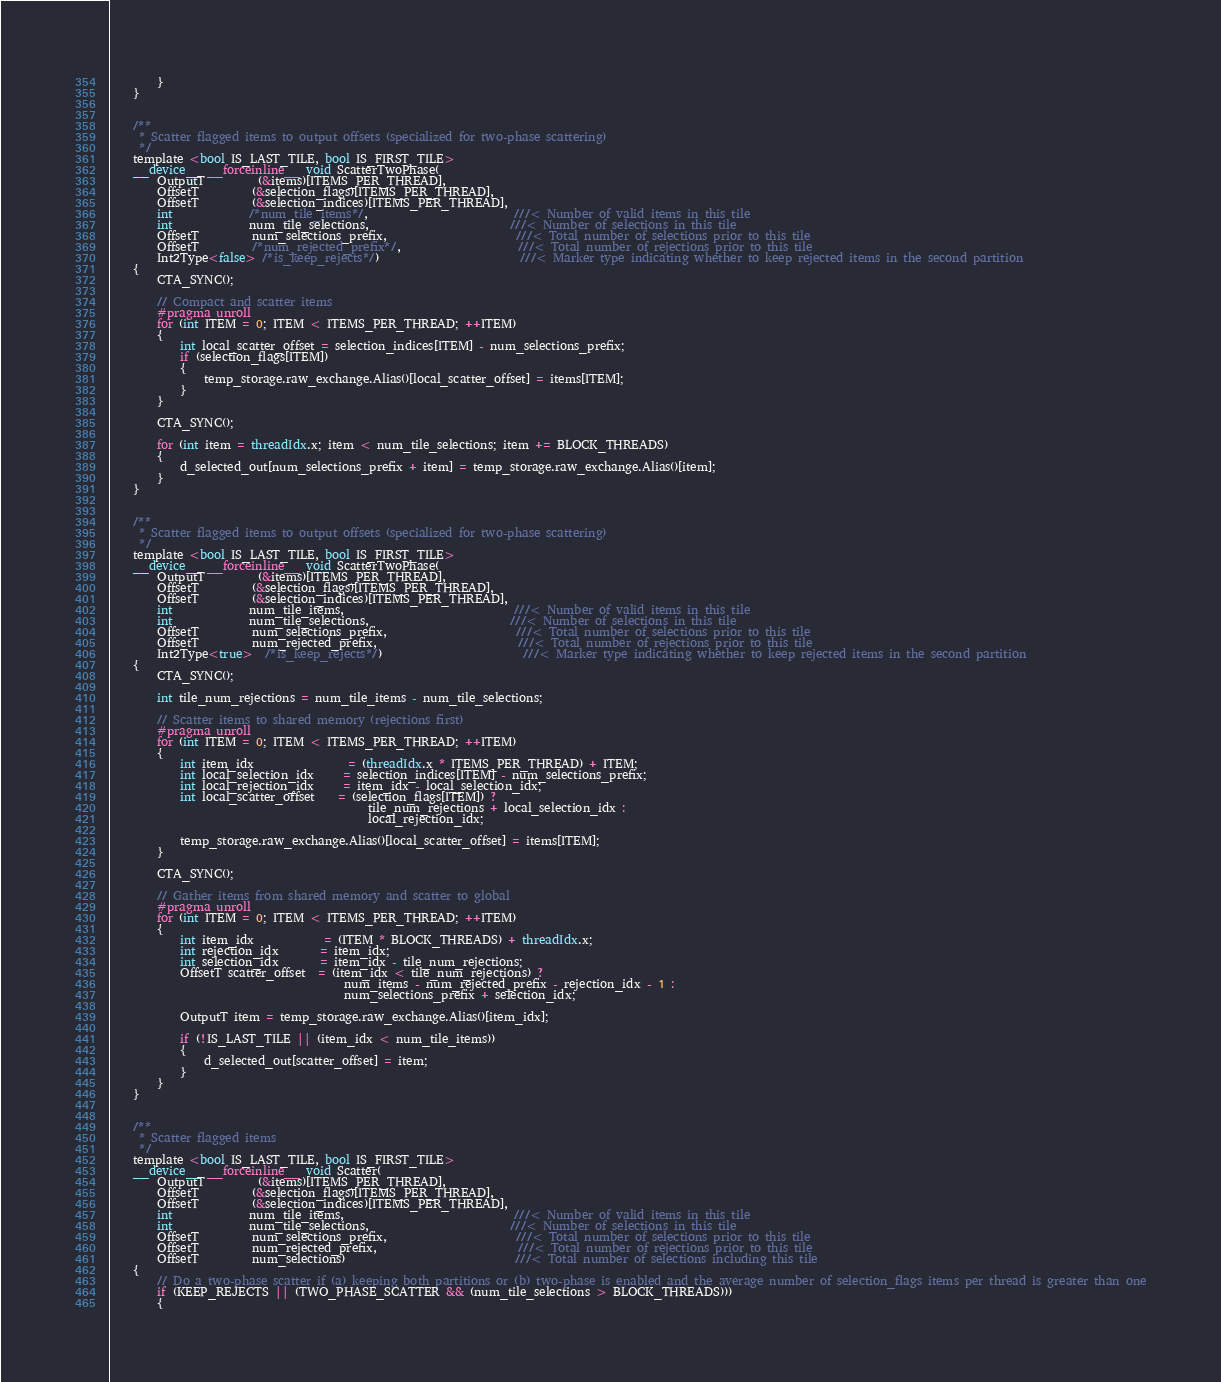<code> <loc_0><loc_0><loc_500><loc_500><_Cuda_>        }
    }


    /**
     * Scatter flagged items to output offsets (specialized for two-phase scattering)
     */
    template <bool IS_LAST_TILE, bool IS_FIRST_TILE>
    __device__ __forceinline__ void ScatterTwoPhase(
        OutputT         (&items)[ITEMS_PER_THREAD],
        OffsetT         (&selection_flags)[ITEMS_PER_THREAD],
        OffsetT         (&selection_indices)[ITEMS_PER_THREAD],
        int             /*num_tile_items*/,                         ///< Number of valid items in this tile
        int             num_tile_selections,                        ///< Number of selections in this tile
        OffsetT         num_selections_prefix,                      ///< Total number of selections prior to this tile
        OffsetT         /*num_rejected_prefix*/,                    ///< Total number of rejections prior to this tile
        Int2Type<false> /*is_keep_rejects*/)                        ///< Marker type indicating whether to keep rejected items in the second partition
    {
        CTA_SYNC();

        // Compact and scatter items
        #pragma unroll
        for (int ITEM = 0; ITEM < ITEMS_PER_THREAD; ++ITEM)
        {
            int local_scatter_offset = selection_indices[ITEM] - num_selections_prefix;
            if (selection_flags[ITEM])
            {
                temp_storage.raw_exchange.Alias()[local_scatter_offset] = items[ITEM];
            }
        }

        CTA_SYNC();

        for (int item = threadIdx.x; item < num_tile_selections; item += BLOCK_THREADS)
        {
            d_selected_out[num_selections_prefix + item] = temp_storage.raw_exchange.Alias()[item];
        }
    }


    /**
     * Scatter flagged items to output offsets (specialized for two-phase scattering)
     */
    template <bool IS_LAST_TILE, bool IS_FIRST_TILE>
    __device__ __forceinline__ void ScatterTwoPhase(
        OutputT         (&items)[ITEMS_PER_THREAD],
        OffsetT         (&selection_flags)[ITEMS_PER_THREAD],
        OffsetT         (&selection_indices)[ITEMS_PER_THREAD],
        int             num_tile_items,                             ///< Number of valid items in this tile
        int             num_tile_selections,                        ///< Number of selections in this tile
        OffsetT         num_selections_prefix,                      ///< Total number of selections prior to this tile
        OffsetT         num_rejected_prefix,                        ///< Total number of rejections prior to this tile
        Int2Type<true>  /*is_keep_rejects*/)                        ///< Marker type indicating whether to keep rejected items in the second partition
    {
        CTA_SYNC();

        int tile_num_rejections = num_tile_items - num_tile_selections;

        // Scatter items to shared memory (rejections first)
        #pragma unroll
        for (int ITEM = 0; ITEM < ITEMS_PER_THREAD; ++ITEM)
        {
            int item_idx                = (threadIdx.x * ITEMS_PER_THREAD) + ITEM;
            int local_selection_idx     = selection_indices[ITEM] - num_selections_prefix;
            int local_rejection_idx     = item_idx - local_selection_idx;
            int local_scatter_offset    = (selection_flags[ITEM]) ?
                                            tile_num_rejections + local_selection_idx :
                                            local_rejection_idx;

            temp_storage.raw_exchange.Alias()[local_scatter_offset] = items[ITEM];
        }

        CTA_SYNC();

        // Gather items from shared memory and scatter to global
        #pragma unroll
        for (int ITEM = 0; ITEM < ITEMS_PER_THREAD; ++ITEM)
        {
            int item_idx            = (ITEM * BLOCK_THREADS) + threadIdx.x;
            int rejection_idx       = item_idx;
            int selection_idx       = item_idx - tile_num_rejections;
            OffsetT scatter_offset  = (item_idx < tile_num_rejections) ?
                                        num_items - num_rejected_prefix - rejection_idx - 1 :
                                        num_selections_prefix + selection_idx;

            OutputT item = temp_storage.raw_exchange.Alias()[item_idx];

            if (!IS_LAST_TILE || (item_idx < num_tile_items))
            {
                d_selected_out[scatter_offset] = item;
            }
        }
    }


    /**
     * Scatter flagged items
     */
    template <bool IS_LAST_TILE, bool IS_FIRST_TILE>
    __device__ __forceinline__ void Scatter(
        OutputT         (&items)[ITEMS_PER_THREAD],
        OffsetT         (&selection_flags)[ITEMS_PER_THREAD],
        OffsetT         (&selection_indices)[ITEMS_PER_THREAD],
        int             num_tile_items,                             ///< Number of valid items in this tile
        int             num_tile_selections,                        ///< Number of selections in this tile
        OffsetT         num_selections_prefix,                      ///< Total number of selections prior to this tile
        OffsetT         num_rejected_prefix,                        ///< Total number of rejections prior to this tile
        OffsetT         num_selections)                             ///< Total number of selections including this tile
    {
        // Do a two-phase scatter if (a) keeping both partitions or (b) two-phase is enabled and the average number of selection_flags items per thread is greater than one
        if (KEEP_REJECTS || (TWO_PHASE_SCATTER && (num_tile_selections > BLOCK_THREADS)))
        {</code> 